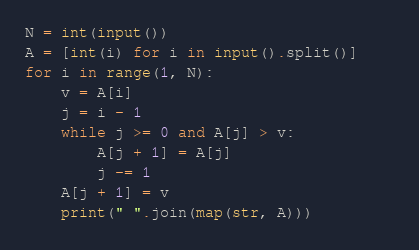Convert code to text. <code><loc_0><loc_0><loc_500><loc_500><_Python_>N = int(input())
A = [int(i) for i in input().split()]    
for i in range(1, N):
    v = A[i]
    j = i - 1
    while j >= 0 and A[j] > v:
        A[j + 1] = A[j]
        j -= 1
    A[j + 1] = v
    print(" ".join(map(str, A)))       </code> 